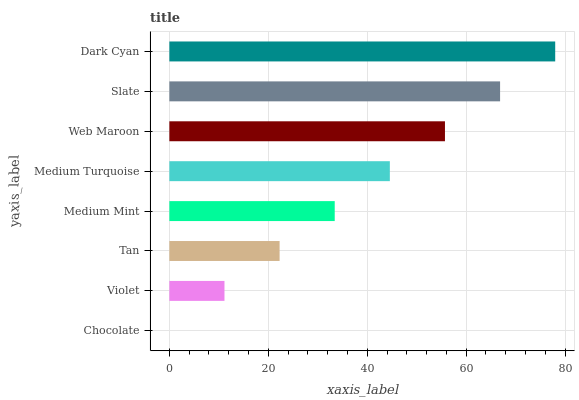Is Chocolate the minimum?
Answer yes or no. Yes. Is Dark Cyan the maximum?
Answer yes or no. Yes. Is Violet the minimum?
Answer yes or no. No. Is Violet the maximum?
Answer yes or no. No. Is Violet greater than Chocolate?
Answer yes or no. Yes. Is Chocolate less than Violet?
Answer yes or no. Yes. Is Chocolate greater than Violet?
Answer yes or no. No. Is Violet less than Chocolate?
Answer yes or no. No. Is Medium Turquoise the high median?
Answer yes or no. Yes. Is Medium Mint the low median?
Answer yes or no. Yes. Is Web Maroon the high median?
Answer yes or no. No. Is Tan the low median?
Answer yes or no. No. 